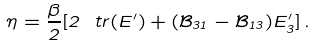<formula> <loc_0><loc_0><loc_500><loc_500>\eta = \frac { \beta } { 2 } [ 2 \ t r ( E ^ { \prime } ) + ( \mathcal { B } _ { 3 1 } - \mathcal { B } _ { 1 3 } ) E ^ { \prime } _ { 3 } ] \, .</formula> 